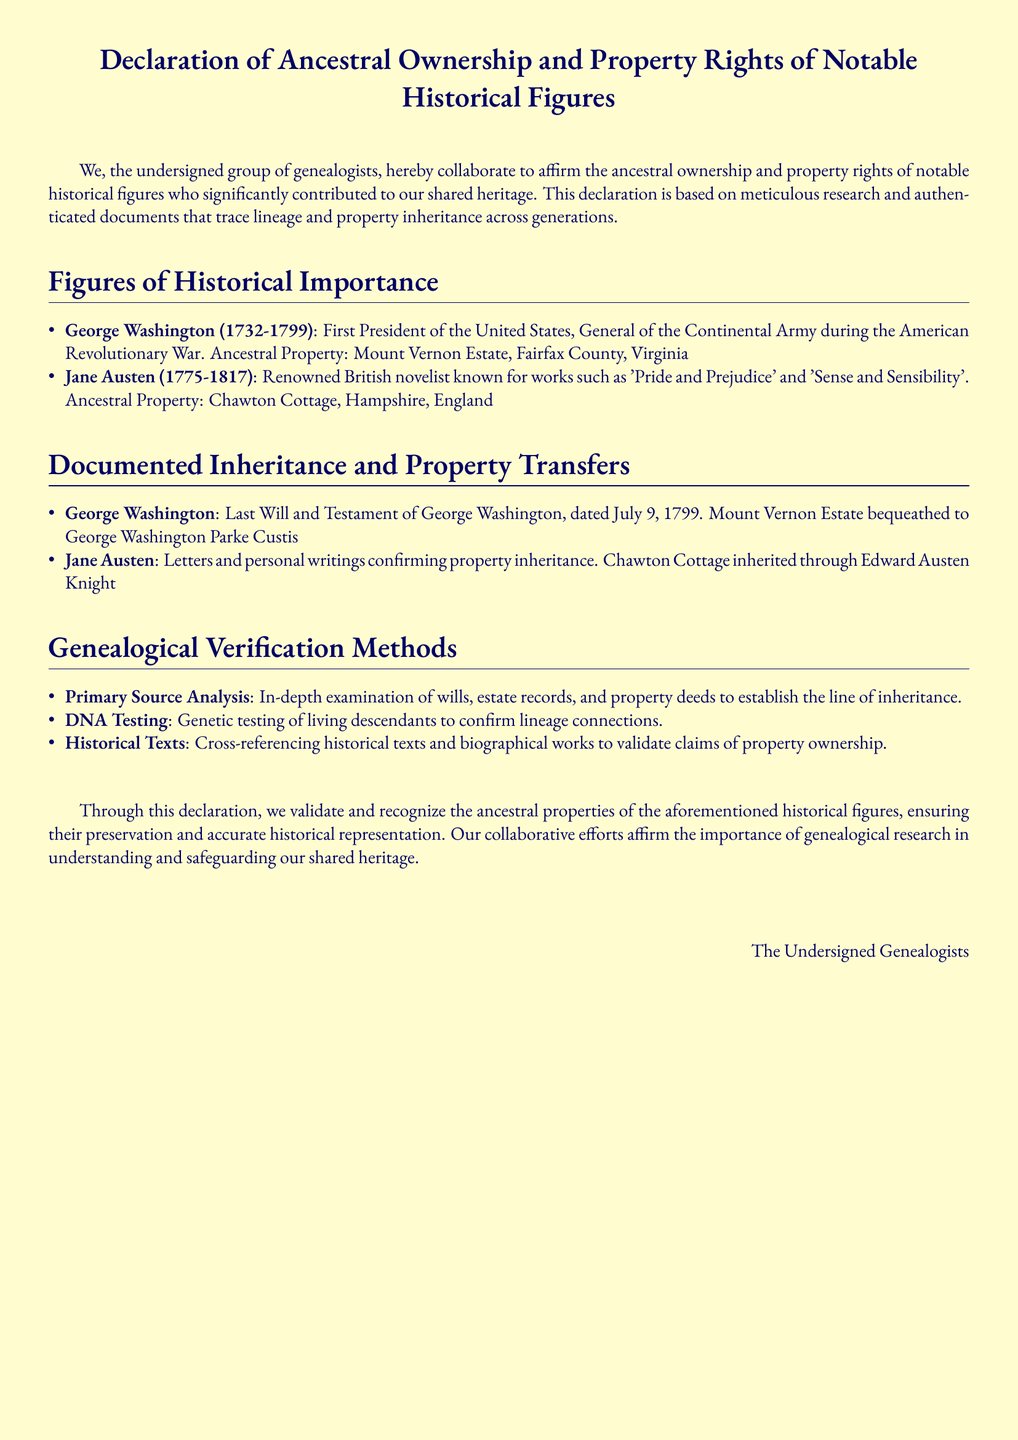What historical figure was the first President of the United States? The document lists George Washington as the first President of the United States.
Answer: George Washington What estate did George Washington inherit? According to the document, George Washington's ancestral property is the Mount Vernon Estate.
Answer: Mount Vernon Estate Who inherited Chawton Cottage from Jane Austen? The document states that Chawton Cottage was inherited through Edward Austen Knight.
Answer: Edward Austen Knight In what year was George Washington's last will and testament dated? The document mentions that George Washington's last will and testament is dated July 9, 1799.
Answer: July 9, 1799 What type of analysis is used to establish the line of inheritance? The document describes primary source analysis as a method used for establishing the line of inheritance.
Answer: Primary Source Analysis How many notable historical figures are mentioned in the document? The document lists two notable historical figures: George Washington and Jane Austen.
Answer: Two What method is mentioned as a way to confirm lineage connections? The document states that DNA testing is used to confirm lineage connections.
Answer: DNA Testing What is the purpose of this declaration? The purpose, as stated in the document, is to validate and recognize the ancestral properties of historical figures.
Answer: Validate and recognize ancestral properties Which historical figure is associated with Chawton Cottage? The document clearly associates Jane Austen with Chawton Cottage.
Answer: Jane Austen 